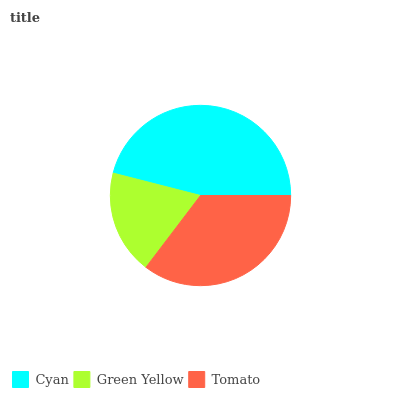Is Green Yellow the minimum?
Answer yes or no. Yes. Is Cyan the maximum?
Answer yes or no. Yes. Is Tomato the minimum?
Answer yes or no. No. Is Tomato the maximum?
Answer yes or no. No. Is Tomato greater than Green Yellow?
Answer yes or no. Yes. Is Green Yellow less than Tomato?
Answer yes or no. Yes. Is Green Yellow greater than Tomato?
Answer yes or no. No. Is Tomato less than Green Yellow?
Answer yes or no. No. Is Tomato the high median?
Answer yes or no. Yes. Is Tomato the low median?
Answer yes or no. Yes. Is Green Yellow the high median?
Answer yes or no. No. Is Cyan the low median?
Answer yes or no. No. 